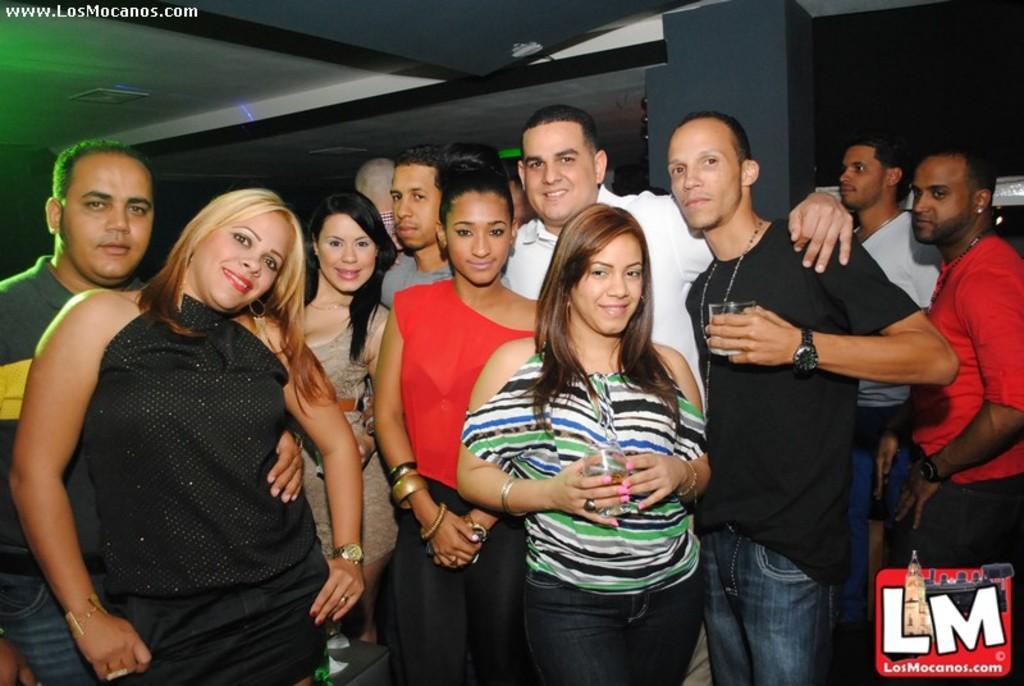Describe this image in one or two sentences. In this image I can see in the middle a woman is standing by holding the wine glass, beside her there is a man also holding the wine glass. Around him a group of people are standing, in the right hand bottom side there is the logo and in the left hand side top there is the water mark. 